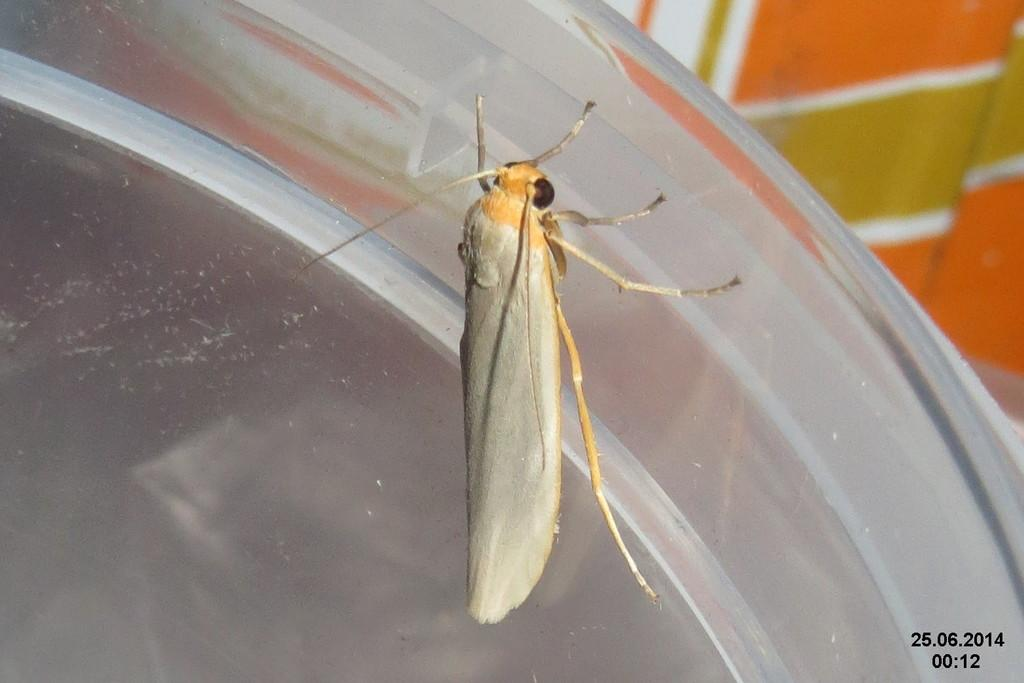What is present on the table in the image? There is a fly on the table in the image. What can be seen in the background of the image? There is a cloth in the background of the image. What type of design can be seen on the rifle in the image? There is no rifle present in the image; it only features a fly on the table and a cloth in the background. 